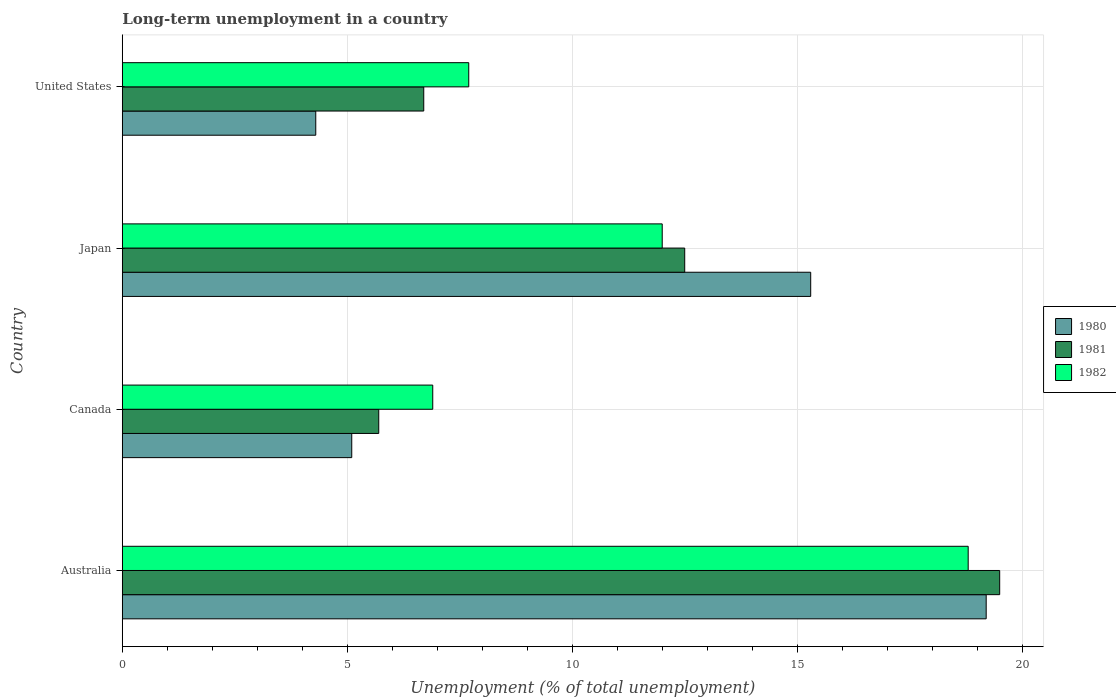Are the number of bars per tick equal to the number of legend labels?
Give a very brief answer. Yes. Are the number of bars on each tick of the Y-axis equal?
Make the answer very short. Yes. How many bars are there on the 4th tick from the bottom?
Ensure brevity in your answer.  3. What is the label of the 4th group of bars from the top?
Make the answer very short. Australia. In how many cases, is the number of bars for a given country not equal to the number of legend labels?
Make the answer very short. 0. What is the percentage of long-term unemployed population in 1981 in Australia?
Offer a terse response. 19.5. Across all countries, what is the maximum percentage of long-term unemployed population in 1980?
Your answer should be compact. 19.2. Across all countries, what is the minimum percentage of long-term unemployed population in 1982?
Provide a short and direct response. 6.9. In which country was the percentage of long-term unemployed population in 1982 maximum?
Your answer should be compact. Australia. In which country was the percentage of long-term unemployed population in 1982 minimum?
Provide a succinct answer. Canada. What is the total percentage of long-term unemployed population in 1982 in the graph?
Offer a terse response. 45.4. What is the difference between the percentage of long-term unemployed population in 1981 in Australia and that in Japan?
Ensure brevity in your answer.  7. What is the difference between the percentage of long-term unemployed population in 1981 in Japan and the percentage of long-term unemployed population in 1980 in Canada?
Offer a terse response. 7.4. What is the average percentage of long-term unemployed population in 1981 per country?
Your answer should be compact. 11.1. What is the difference between the percentage of long-term unemployed population in 1980 and percentage of long-term unemployed population in 1982 in Japan?
Make the answer very short. 3.3. In how many countries, is the percentage of long-term unemployed population in 1981 greater than 18 %?
Offer a very short reply. 1. What is the ratio of the percentage of long-term unemployed population in 1982 in Canada to that in Japan?
Your answer should be very brief. 0.58. Is the percentage of long-term unemployed population in 1982 in Japan less than that in United States?
Keep it short and to the point. No. What is the difference between the highest and the lowest percentage of long-term unemployed population in 1982?
Your answer should be very brief. 11.9. In how many countries, is the percentage of long-term unemployed population in 1981 greater than the average percentage of long-term unemployed population in 1981 taken over all countries?
Give a very brief answer. 2. How many bars are there?
Your answer should be compact. 12. Does the graph contain grids?
Provide a short and direct response. Yes. Where does the legend appear in the graph?
Make the answer very short. Center right. How many legend labels are there?
Your answer should be compact. 3. What is the title of the graph?
Your answer should be compact. Long-term unemployment in a country. Does "1961" appear as one of the legend labels in the graph?
Provide a short and direct response. No. What is the label or title of the X-axis?
Your response must be concise. Unemployment (% of total unemployment). What is the Unemployment (% of total unemployment) in 1980 in Australia?
Make the answer very short. 19.2. What is the Unemployment (% of total unemployment) of 1982 in Australia?
Provide a short and direct response. 18.8. What is the Unemployment (% of total unemployment) in 1980 in Canada?
Your response must be concise. 5.1. What is the Unemployment (% of total unemployment) of 1981 in Canada?
Your answer should be very brief. 5.7. What is the Unemployment (% of total unemployment) in 1982 in Canada?
Your answer should be compact. 6.9. What is the Unemployment (% of total unemployment) in 1980 in Japan?
Make the answer very short. 15.3. What is the Unemployment (% of total unemployment) of 1981 in Japan?
Provide a succinct answer. 12.5. What is the Unemployment (% of total unemployment) in 1980 in United States?
Your answer should be compact. 4.3. What is the Unemployment (% of total unemployment) of 1981 in United States?
Keep it short and to the point. 6.7. What is the Unemployment (% of total unemployment) in 1982 in United States?
Your answer should be very brief. 7.7. Across all countries, what is the maximum Unemployment (% of total unemployment) of 1980?
Offer a very short reply. 19.2. Across all countries, what is the maximum Unemployment (% of total unemployment) in 1982?
Provide a succinct answer. 18.8. Across all countries, what is the minimum Unemployment (% of total unemployment) of 1980?
Your answer should be compact. 4.3. Across all countries, what is the minimum Unemployment (% of total unemployment) of 1981?
Give a very brief answer. 5.7. Across all countries, what is the minimum Unemployment (% of total unemployment) of 1982?
Offer a terse response. 6.9. What is the total Unemployment (% of total unemployment) of 1980 in the graph?
Ensure brevity in your answer.  43.9. What is the total Unemployment (% of total unemployment) of 1981 in the graph?
Offer a very short reply. 44.4. What is the total Unemployment (% of total unemployment) of 1982 in the graph?
Your answer should be compact. 45.4. What is the difference between the Unemployment (% of total unemployment) in 1981 in Australia and that in Canada?
Offer a very short reply. 13.8. What is the difference between the Unemployment (% of total unemployment) of 1982 in Australia and that in Canada?
Offer a very short reply. 11.9. What is the difference between the Unemployment (% of total unemployment) in 1980 in Australia and that in Japan?
Offer a terse response. 3.9. What is the difference between the Unemployment (% of total unemployment) in 1982 in Australia and that in United States?
Ensure brevity in your answer.  11.1. What is the difference between the Unemployment (% of total unemployment) in 1981 in Canada and that in Japan?
Give a very brief answer. -6.8. What is the difference between the Unemployment (% of total unemployment) of 1981 in Canada and that in United States?
Ensure brevity in your answer.  -1. What is the difference between the Unemployment (% of total unemployment) of 1982 in Canada and that in United States?
Provide a succinct answer. -0.8. What is the difference between the Unemployment (% of total unemployment) in 1981 in Japan and that in United States?
Your answer should be very brief. 5.8. What is the difference between the Unemployment (% of total unemployment) in 1980 in Australia and the Unemployment (% of total unemployment) in 1982 in Canada?
Give a very brief answer. 12.3. What is the difference between the Unemployment (% of total unemployment) in 1980 in Australia and the Unemployment (% of total unemployment) in 1982 in Japan?
Keep it short and to the point. 7.2. What is the difference between the Unemployment (% of total unemployment) in 1981 in Australia and the Unemployment (% of total unemployment) in 1982 in Japan?
Provide a succinct answer. 7.5. What is the difference between the Unemployment (% of total unemployment) in 1980 in Australia and the Unemployment (% of total unemployment) in 1981 in United States?
Provide a succinct answer. 12.5. What is the difference between the Unemployment (% of total unemployment) of 1980 in Australia and the Unemployment (% of total unemployment) of 1982 in United States?
Give a very brief answer. 11.5. What is the difference between the Unemployment (% of total unemployment) in 1981 in Australia and the Unemployment (% of total unemployment) in 1982 in United States?
Offer a terse response. 11.8. What is the difference between the Unemployment (% of total unemployment) in 1980 in Canada and the Unemployment (% of total unemployment) in 1981 in Japan?
Make the answer very short. -7.4. What is the difference between the Unemployment (% of total unemployment) in 1980 in Canada and the Unemployment (% of total unemployment) in 1982 in Japan?
Provide a succinct answer. -6.9. What is the difference between the Unemployment (% of total unemployment) of 1980 in Japan and the Unemployment (% of total unemployment) of 1981 in United States?
Provide a succinct answer. 8.6. What is the difference between the Unemployment (% of total unemployment) in 1981 in Japan and the Unemployment (% of total unemployment) in 1982 in United States?
Provide a short and direct response. 4.8. What is the average Unemployment (% of total unemployment) in 1980 per country?
Provide a succinct answer. 10.97. What is the average Unemployment (% of total unemployment) of 1982 per country?
Your response must be concise. 11.35. What is the difference between the Unemployment (% of total unemployment) of 1980 and Unemployment (% of total unemployment) of 1981 in Australia?
Make the answer very short. -0.3. What is the difference between the Unemployment (% of total unemployment) in 1980 and Unemployment (% of total unemployment) in 1982 in Australia?
Make the answer very short. 0.4. What is the difference between the Unemployment (% of total unemployment) in 1981 and Unemployment (% of total unemployment) in 1982 in Australia?
Provide a short and direct response. 0.7. What is the difference between the Unemployment (% of total unemployment) in 1980 and Unemployment (% of total unemployment) in 1981 in Canada?
Keep it short and to the point. -0.6. What is the difference between the Unemployment (% of total unemployment) of 1980 and Unemployment (% of total unemployment) of 1982 in Canada?
Provide a succinct answer. -1.8. What is the difference between the Unemployment (% of total unemployment) in 1980 and Unemployment (% of total unemployment) in 1982 in Japan?
Your answer should be very brief. 3.3. What is the ratio of the Unemployment (% of total unemployment) in 1980 in Australia to that in Canada?
Your answer should be very brief. 3.76. What is the ratio of the Unemployment (% of total unemployment) in 1981 in Australia to that in Canada?
Make the answer very short. 3.42. What is the ratio of the Unemployment (% of total unemployment) of 1982 in Australia to that in Canada?
Offer a terse response. 2.72. What is the ratio of the Unemployment (% of total unemployment) in 1980 in Australia to that in Japan?
Your answer should be compact. 1.25. What is the ratio of the Unemployment (% of total unemployment) in 1981 in Australia to that in Japan?
Make the answer very short. 1.56. What is the ratio of the Unemployment (% of total unemployment) in 1982 in Australia to that in Japan?
Your answer should be very brief. 1.57. What is the ratio of the Unemployment (% of total unemployment) of 1980 in Australia to that in United States?
Your answer should be compact. 4.47. What is the ratio of the Unemployment (% of total unemployment) of 1981 in Australia to that in United States?
Keep it short and to the point. 2.91. What is the ratio of the Unemployment (% of total unemployment) in 1982 in Australia to that in United States?
Provide a short and direct response. 2.44. What is the ratio of the Unemployment (% of total unemployment) in 1980 in Canada to that in Japan?
Give a very brief answer. 0.33. What is the ratio of the Unemployment (% of total unemployment) in 1981 in Canada to that in Japan?
Your answer should be compact. 0.46. What is the ratio of the Unemployment (% of total unemployment) in 1982 in Canada to that in Japan?
Your answer should be very brief. 0.57. What is the ratio of the Unemployment (% of total unemployment) of 1980 in Canada to that in United States?
Make the answer very short. 1.19. What is the ratio of the Unemployment (% of total unemployment) in 1981 in Canada to that in United States?
Ensure brevity in your answer.  0.85. What is the ratio of the Unemployment (% of total unemployment) in 1982 in Canada to that in United States?
Your answer should be compact. 0.9. What is the ratio of the Unemployment (% of total unemployment) of 1980 in Japan to that in United States?
Provide a short and direct response. 3.56. What is the ratio of the Unemployment (% of total unemployment) in 1981 in Japan to that in United States?
Ensure brevity in your answer.  1.87. What is the ratio of the Unemployment (% of total unemployment) of 1982 in Japan to that in United States?
Provide a short and direct response. 1.56. What is the difference between the highest and the lowest Unemployment (% of total unemployment) of 1981?
Ensure brevity in your answer.  13.8. What is the difference between the highest and the lowest Unemployment (% of total unemployment) in 1982?
Offer a very short reply. 11.9. 